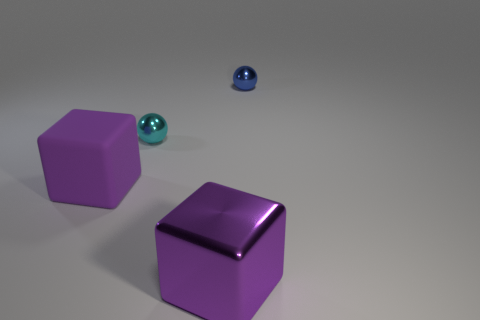Subtract all blue blocks. Subtract all gray spheres. How many blocks are left? 2 Add 2 tiny metal spheres. How many objects exist? 6 Subtract 0 brown cylinders. How many objects are left? 4 Subtract all tiny blue objects. Subtract all cubes. How many objects are left? 1 Add 3 big purple rubber cubes. How many big purple rubber cubes are left? 4 Add 4 spheres. How many spheres exist? 6 